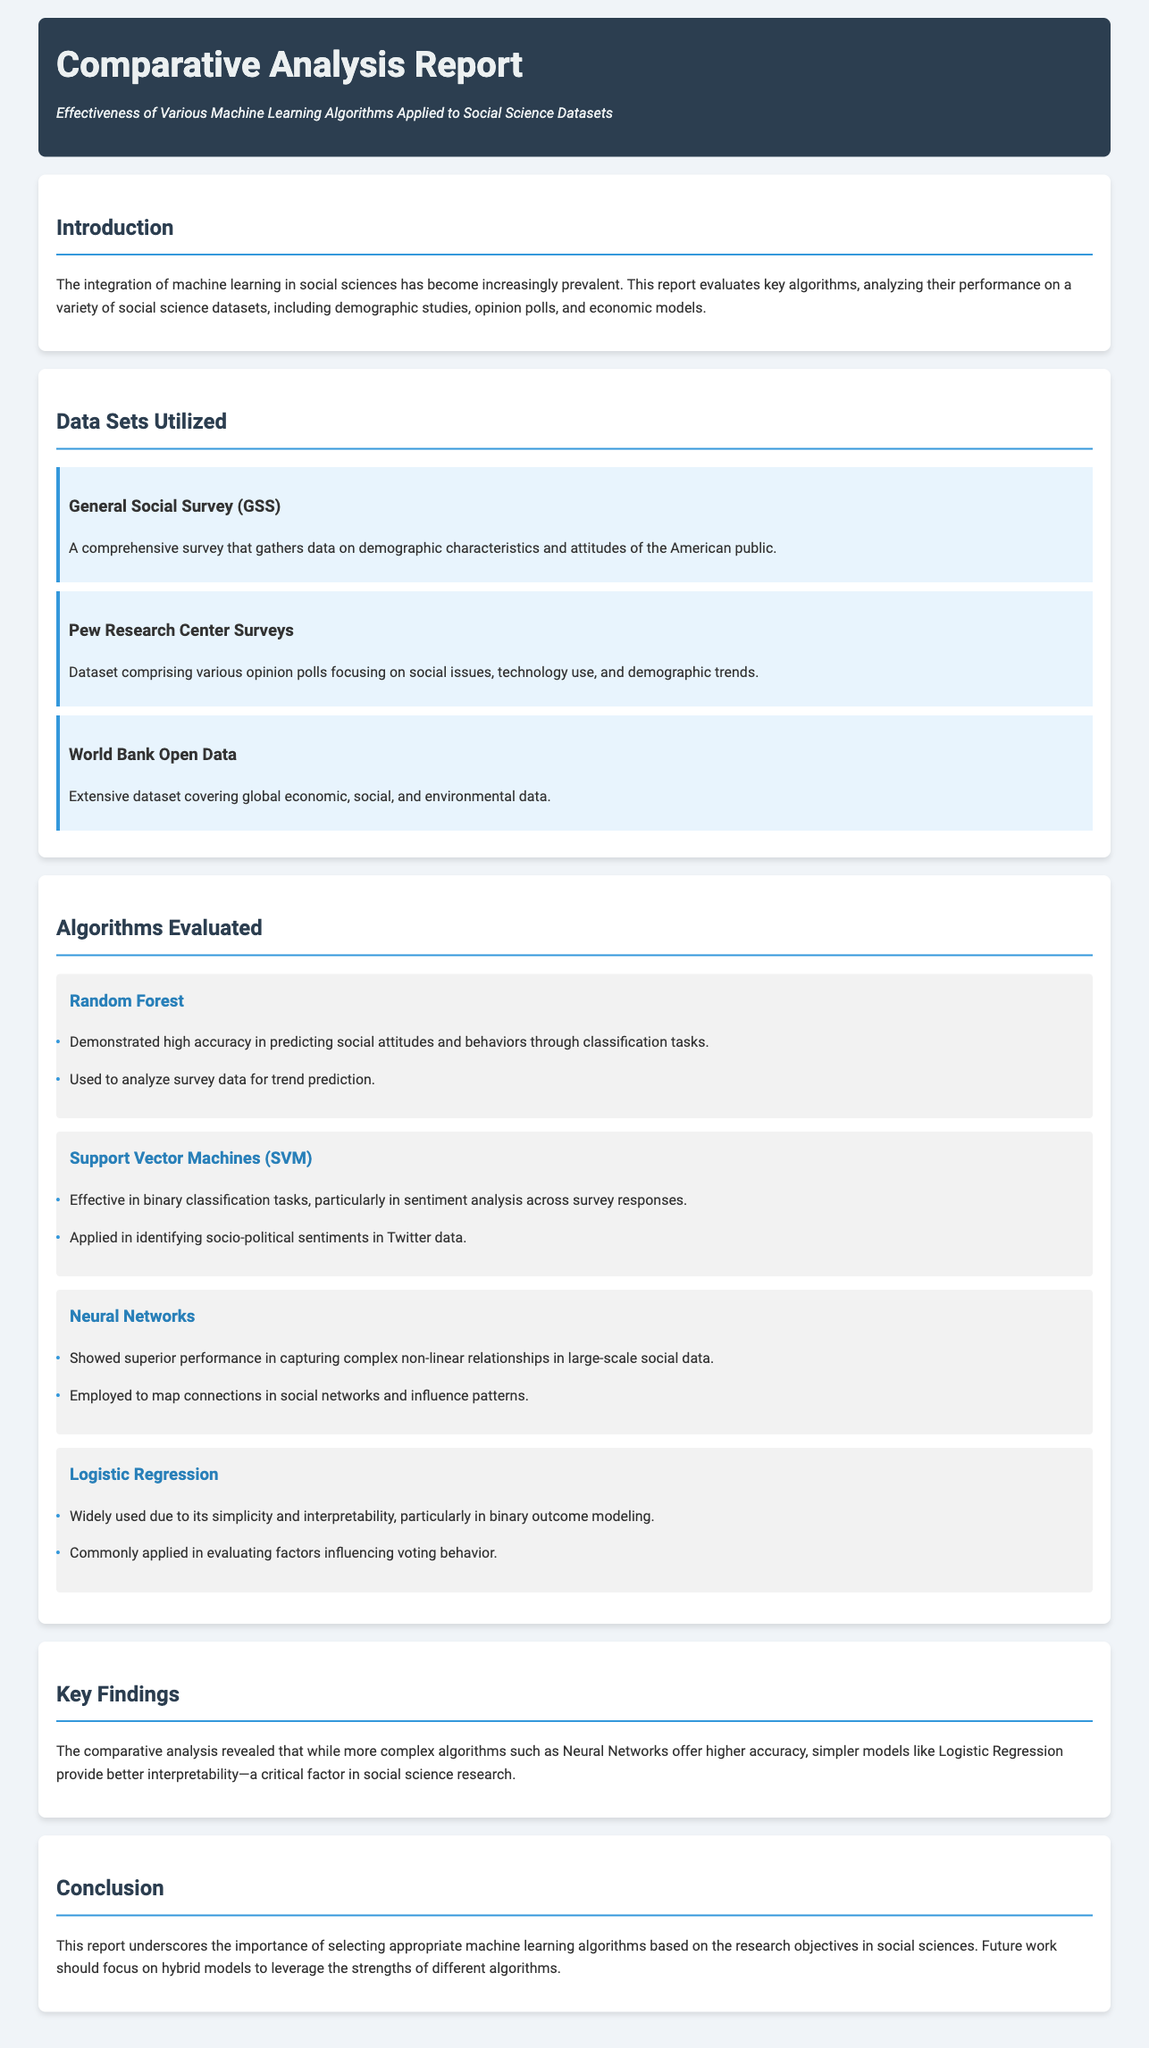What is the title of the report? The title of the report is stated in the header section of the document.
Answer: Comparative Analysis Report What is the first dataset mentioned? The first dataset is listed in the "Data Sets Utilized" section of the document.
Answer: General Social Survey (GSS) Which algorithm is effective in binary classification tasks? This information is found in the "Algorithms Evaluated" section, describing Support Vector Machines.
Answer: Support Vector Machines (SVM) What key finding is highlighted in the analysis? The key finding discusses the balance between accuracy and interpretability of algorithms.
Answer: Complexity vs. Interpretability What type of data does the World Bank Open Data cover? This information is available in the "Data Sets Utilized" section, specifying the nature of the dataset.
Answer: Economic, social, and environmental data Which algorithm showed superior performance in capturing complex relationships? This is detailed in the "Algorithms Evaluated" section, referring to the capabilities of Neural Networks.
Answer: Neural Networks What does the report suggest for future work? The conclusion of the report pertains to recommended directions for future research.
Answer: Hybrid models What survey focuses on social issues and technology use? This detail is found in the "Data Sets Utilized" section referring to the Pew Research Center Surveys.
Answer: Pew Research Center Surveys 